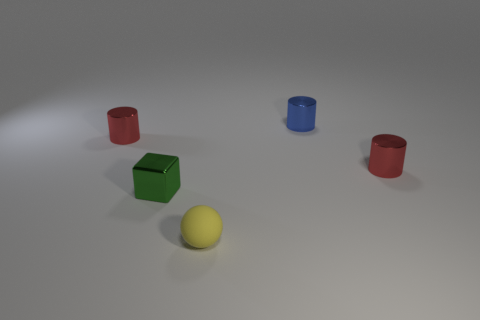What is the color of the cube that is made of the same material as the small blue cylinder?
Your answer should be very brief. Green. Is there a matte thing in front of the cylinder right of the blue metal thing?
Give a very brief answer. Yes. There is a shiny block that is the same size as the yellow rubber sphere; what is its color?
Your answer should be compact. Green. How many objects are either small yellow rubber balls or small metallic blocks?
Your answer should be very brief. 2. How big is the cylinder in front of the cylinder that is left of the tiny matte thing in front of the tiny blue cylinder?
Keep it short and to the point. Small. What number of cylinders have the same color as the block?
Your answer should be compact. 0. What number of other small yellow balls have the same material as the yellow ball?
Make the answer very short. 0. What number of things are either large purple metallic cylinders or tiny red objects that are right of the green cube?
Make the answer very short. 1. There is a tiny cylinder in front of the tiny red metallic cylinder that is left of the tiny red metallic thing that is to the right of the green block; what is its color?
Your answer should be compact. Red. What size is the thing to the left of the block?
Offer a terse response. Small. 